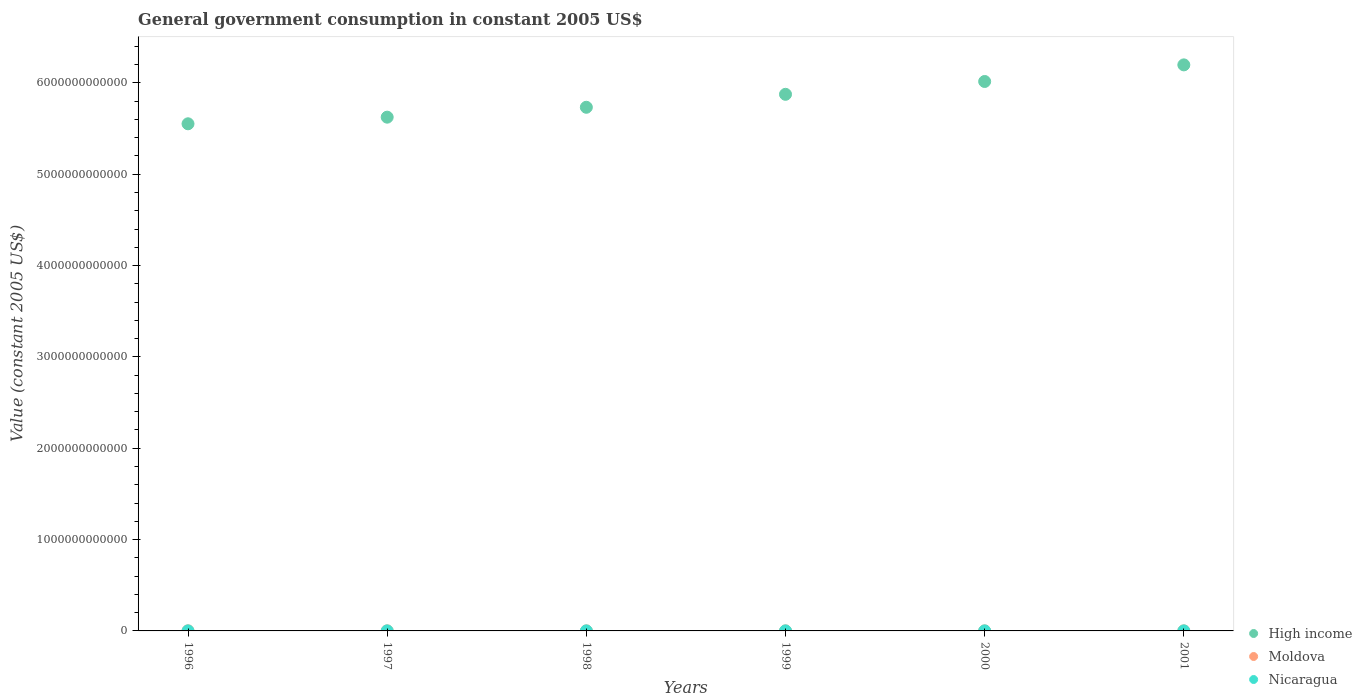How many different coloured dotlines are there?
Keep it short and to the point. 3. What is the government conusmption in Nicaragua in 1999?
Your answer should be very brief. 5.27e+08. Across all years, what is the maximum government conusmption in High income?
Your answer should be compact. 6.20e+12. Across all years, what is the minimum government conusmption in Moldova?
Keep it short and to the point. 2.83e+08. In which year was the government conusmption in Moldova minimum?
Make the answer very short. 1999. What is the total government conusmption in Moldova in the graph?
Ensure brevity in your answer.  2.62e+09. What is the difference between the government conusmption in Moldova in 1997 and that in 2000?
Offer a terse response. 2.41e+08. What is the difference between the government conusmption in Moldova in 1997 and the government conusmption in High income in 2001?
Offer a very short reply. -6.20e+12. What is the average government conusmption in High income per year?
Make the answer very short. 5.83e+12. In the year 1999, what is the difference between the government conusmption in Nicaragua and government conusmption in High income?
Provide a short and direct response. -5.87e+12. What is the ratio of the government conusmption in High income in 1997 to that in 1998?
Offer a terse response. 0.98. What is the difference between the highest and the second highest government conusmption in Moldova?
Offer a terse response. 2.06e+08. What is the difference between the highest and the lowest government conusmption in Nicaragua?
Make the answer very short. 8.57e+07. In how many years, is the government conusmption in Moldova greater than the average government conusmption in Moldova taken over all years?
Make the answer very short. 2. Is the sum of the government conusmption in High income in 1997 and 2000 greater than the maximum government conusmption in Nicaragua across all years?
Keep it short and to the point. Yes. Is it the case that in every year, the sum of the government conusmption in High income and government conusmption in Nicaragua  is greater than the government conusmption in Moldova?
Offer a very short reply. Yes. Does the government conusmption in Nicaragua monotonically increase over the years?
Your response must be concise. No. Is the government conusmption in Moldova strictly greater than the government conusmption in High income over the years?
Your answer should be compact. No. Is the government conusmption in Nicaragua strictly less than the government conusmption in High income over the years?
Offer a terse response. Yes. How many years are there in the graph?
Offer a terse response. 6. What is the difference between two consecutive major ticks on the Y-axis?
Keep it short and to the point. 1.00e+12. Are the values on the major ticks of Y-axis written in scientific E-notation?
Your answer should be very brief. No. How many legend labels are there?
Give a very brief answer. 3. How are the legend labels stacked?
Provide a succinct answer. Vertical. What is the title of the graph?
Give a very brief answer. General government consumption in constant 2005 US$. Does "Kyrgyz Republic" appear as one of the legend labels in the graph?
Provide a succinct answer. No. What is the label or title of the Y-axis?
Offer a very short reply. Value (constant 2005 US$). What is the Value (constant 2005 US$) of High income in 1996?
Offer a terse response. 5.55e+12. What is the Value (constant 2005 US$) in Moldova in 1996?
Offer a very short reply. 7.36e+08. What is the Value (constant 2005 US$) of Nicaragua in 1996?
Make the answer very short. 4.87e+08. What is the Value (constant 2005 US$) of High income in 1997?
Your answer should be compact. 5.63e+12. What is the Value (constant 2005 US$) of Moldova in 1997?
Provide a short and direct response. 5.30e+08. What is the Value (constant 2005 US$) in Nicaragua in 1997?
Keep it short and to the point. 4.67e+08. What is the Value (constant 2005 US$) in High income in 1998?
Your response must be concise. 5.73e+12. What is the Value (constant 2005 US$) in Moldova in 1998?
Keep it short and to the point. 3.69e+08. What is the Value (constant 2005 US$) of Nicaragua in 1998?
Your answer should be compact. 4.87e+08. What is the Value (constant 2005 US$) of High income in 1999?
Provide a short and direct response. 5.88e+12. What is the Value (constant 2005 US$) of Moldova in 1999?
Make the answer very short. 2.83e+08. What is the Value (constant 2005 US$) in Nicaragua in 1999?
Provide a succinct answer. 5.27e+08. What is the Value (constant 2005 US$) in High income in 2000?
Offer a very short reply. 6.02e+12. What is the Value (constant 2005 US$) in Moldova in 2000?
Keep it short and to the point. 2.89e+08. What is the Value (constant 2005 US$) of Nicaragua in 2000?
Keep it short and to the point. 5.53e+08. What is the Value (constant 2005 US$) of High income in 2001?
Offer a terse response. 6.20e+12. What is the Value (constant 2005 US$) of Moldova in 2001?
Offer a terse response. 4.10e+08. What is the Value (constant 2005 US$) in Nicaragua in 2001?
Offer a terse response. 5.37e+08. Across all years, what is the maximum Value (constant 2005 US$) in High income?
Offer a very short reply. 6.20e+12. Across all years, what is the maximum Value (constant 2005 US$) in Moldova?
Offer a very short reply. 7.36e+08. Across all years, what is the maximum Value (constant 2005 US$) of Nicaragua?
Offer a terse response. 5.53e+08. Across all years, what is the minimum Value (constant 2005 US$) of High income?
Your answer should be compact. 5.55e+12. Across all years, what is the minimum Value (constant 2005 US$) of Moldova?
Provide a short and direct response. 2.83e+08. Across all years, what is the minimum Value (constant 2005 US$) in Nicaragua?
Keep it short and to the point. 4.67e+08. What is the total Value (constant 2005 US$) of High income in the graph?
Offer a very short reply. 3.50e+13. What is the total Value (constant 2005 US$) of Moldova in the graph?
Offer a terse response. 2.62e+09. What is the total Value (constant 2005 US$) in Nicaragua in the graph?
Keep it short and to the point. 3.06e+09. What is the difference between the Value (constant 2005 US$) of High income in 1996 and that in 1997?
Provide a short and direct response. -7.26e+1. What is the difference between the Value (constant 2005 US$) in Moldova in 1996 and that in 1997?
Your response must be concise. 2.06e+08. What is the difference between the Value (constant 2005 US$) in Nicaragua in 1996 and that in 1997?
Your response must be concise. 2.01e+07. What is the difference between the Value (constant 2005 US$) in High income in 1996 and that in 1998?
Offer a terse response. -1.81e+11. What is the difference between the Value (constant 2005 US$) of Moldova in 1996 and that in 1998?
Make the answer very short. 3.68e+08. What is the difference between the Value (constant 2005 US$) in Nicaragua in 1996 and that in 1998?
Ensure brevity in your answer.  -2.91e+05. What is the difference between the Value (constant 2005 US$) in High income in 1996 and that in 1999?
Make the answer very short. -3.23e+11. What is the difference between the Value (constant 2005 US$) of Moldova in 1996 and that in 1999?
Provide a short and direct response. 4.53e+08. What is the difference between the Value (constant 2005 US$) in Nicaragua in 1996 and that in 1999?
Your response must be concise. -4.02e+07. What is the difference between the Value (constant 2005 US$) of High income in 1996 and that in 2000?
Offer a terse response. -4.63e+11. What is the difference between the Value (constant 2005 US$) of Moldova in 1996 and that in 2000?
Your answer should be compact. 4.47e+08. What is the difference between the Value (constant 2005 US$) of Nicaragua in 1996 and that in 2000?
Keep it short and to the point. -6.56e+07. What is the difference between the Value (constant 2005 US$) of High income in 1996 and that in 2001?
Provide a short and direct response. -6.45e+11. What is the difference between the Value (constant 2005 US$) in Moldova in 1996 and that in 2001?
Your answer should be compact. 3.26e+08. What is the difference between the Value (constant 2005 US$) in Nicaragua in 1996 and that in 2001?
Provide a short and direct response. -4.96e+07. What is the difference between the Value (constant 2005 US$) in High income in 1997 and that in 1998?
Ensure brevity in your answer.  -1.08e+11. What is the difference between the Value (constant 2005 US$) of Moldova in 1997 and that in 1998?
Provide a short and direct response. 1.61e+08. What is the difference between the Value (constant 2005 US$) of Nicaragua in 1997 and that in 1998?
Offer a terse response. -2.04e+07. What is the difference between the Value (constant 2005 US$) in High income in 1997 and that in 1999?
Keep it short and to the point. -2.50e+11. What is the difference between the Value (constant 2005 US$) in Moldova in 1997 and that in 1999?
Make the answer very short. 2.47e+08. What is the difference between the Value (constant 2005 US$) of Nicaragua in 1997 and that in 1999?
Offer a terse response. -6.04e+07. What is the difference between the Value (constant 2005 US$) in High income in 1997 and that in 2000?
Keep it short and to the point. -3.91e+11. What is the difference between the Value (constant 2005 US$) of Moldova in 1997 and that in 2000?
Offer a terse response. 2.41e+08. What is the difference between the Value (constant 2005 US$) of Nicaragua in 1997 and that in 2000?
Ensure brevity in your answer.  -8.57e+07. What is the difference between the Value (constant 2005 US$) in High income in 1997 and that in 2001?
Offer a terse response. -5.73e+11. What is the difference between the Value (constant 2005 US$) of Moldova in 1997 and that in 2001?
Give a very brief answer. 1.20e+08. What is the difference between the Value (constant 2005 US$) of Nicaragua in 1997 and that in 2001?
Offer a terse response. -6.97e+07. What is the difference between the Value (constant 2005 US$) in High income in 1998 and that in 1999?
Provide a short and direct response. -1.42e+11. What is the difference between the Value (constant 2005 US$) in Moldova in 1998 and that in 1999?
Give a very brief answer. 8.54e+07. What is the difference between the Value (constant 2005 US$) of Nicaragua in 1998 and that in 1999?
Keep it short and to the point. -3.99e+07. What is the difference between the Value (constant 2005 US$) in High income in 1998 and that in 2000?
Your answer should be very brief. -2.82e+11. What is the difference between the Value (constant 2005 US$) of Moldova in 1998 and that in 2000?
Provide a succinct answer. 7.98e+07. What is the difference between the Value (constant 2005 US$) of Nicaragua in 1998 and that in 2000?
Give a very brief answer. -6.53e+07. What is the difference between the Value (constant 2005 US$) of High income in 1998 and that in 2001?
Ensure brevity in your answer.  -4.64e+11. What is the difference between the Value (constant 2005 US$) in Moldova in 1998 and that in 2001?
Offer a very short reply. -4.18e+07. What is the difference between the Value (constant 2005 US$) of Nicaragua in 1998 and that in 2001?
Make the answer very short. -4.93e+07. What is the difference between the Value (constant 2005 US$) in High income in 1999 and that in 2000?
Your answer should be compact. -1.40e+11. What is the difference between the Value (constant 2005 US$) of Moldova in 1999 and that in 2000?
Offer a very short reply. -5.61e+06. What is the difference between the Value (constant 2005 US$) of Nicaragua in 1999 and that in 2000?
Your answer should be very brief. -2.54e+07. What is the difference between the Value (constant 2005 US$) in High income in 1999 and that in 2001?
Provide a succinct answer. -3.22e+11. What is the difference between the Value (constant 2005 US$) in Moldova in 1999 and that in 2001?
Provide a short and direct response. -1.27e+08. What is the difference between the Value (constant 2005 US$) in Nicaragua in 1999 and that in 2001?
Give a very brief answer. -9.35e+06. What is the difference between the Value (constant 2005 US$) of High income in 2000 and that in 2001?
Keep it short and to the point. -1.82e+11. What is the difference between the Value (constant 2005 US$) of Moldova in 2000 and that in 2001?
Offer a very short reply. -1.22e+08. What is the difference between the Value (constant 2005 US$) of Nicaragua in 2000 and that in 2001?
Ensure brevity in your answer.  1.60e+07. What is the difference between the Value (constant 2005 US$) of High income in 1996 and the Value (constant 2005 US$) of Moldova in 1997?
Give a very brief answer. 5.55e+12. What is the difference between the Value (constant 2005 US$) in High income in 1996 and the Value (constant 2005 US$) in Nicaragua in 1997?
Offer a very short reply. 5.55e+12. What is the difference between the Value (constant 2005 US$) in Moldova in 1996 and the Value (constant 2005 US$) in Nicaragua in 1997?
Offer a very short reply. 2.69e+08. What is the difference between the Value (constant 2005 US$) in High income in 1996 and the Value (constant 2005 US$) in Moldova in 1998?
Offer a terse response. 5.55e+12. What is the difference between the Value (constant 2005 US$) in High income in 1996 and the Value (constant 2005 US$) in Nicaragua in 1998?
Make the answer very short. 5.55e+12. What is the difference between the Value (constant 2005 US$) in Moldova in 1996 and the Value (constant 2005 US$) in Nicaragua in 1998?
Provide a short and direct response. 2.49e+08. What is the difference between the Value (constant 2005 US$) in High income in 1996 and the Value (constant 2005 US$) in Moldova in 1999?
Your answer should be compact. 5.55e+12. What is the difference between the Value (constant 2005 US$) of High income in 1996 and the Value (constant 2005 US$) of Nicaragua in 1999?
Provide a succinct answer. 5.55e+12. What is the difference between the Value (constant 2005 US$) of Moldova in 1996 and the Value (constant 2005 US$) of Nicaragua in 1999?
Offer a terse response. 2.09e+08. What is the difference between the Value (constant 2005 US$) in High income in 1996 and the Value (constant 2005 US$) in Moldova in 2000?
Your answer should be very brief. 5.55e+12. What is the difference between the Value (constant 2005 US$) of High income in 1996 and the Value (constant 2005 US$) of Nicaragua in 2000?
Provide a succinct answer. 5.55e+12. What is the difference between the Value (constant 2005 US$) in Moldova in 1996 and the Value (constant 2005 US$) in Nicaragua in 2000?
Provide a short and direct response. 1.84e+08. What is the difference between the Value (constant 2005 US$) of High income in 1996 and the Value (constant 2005 US$) of Moldova in 2001?
Keep it short and to the point. 5.55e+12. What is the difference between the Value (constant 2005 US$) in High income in 1996 and the Value (constant 2005 US$) in Nicaragua in 2001?
Give a very brief answer. 5.55e+12. What is the difference between the Value (constant 2005 US$) of Moldova in 1996 and the Value (constant 2005 US$) of Nicaragua in 2001?
Offer a very short reply. 2.00e+08. What is the difference between the Value (constant 2005 US$) in High income in 1997 and the Value (constant 2005 US$) in Moldova in 1998?
Make the answer very short. 5.62e+12. What is the difference between the Value (constant 2005 US$) of High income in 1997 and the Value (constant 2005 US$) of Nicaragua in 1998?
Your answer should be compact. 5.62e+12. What is the difference between the Value (constant 2005 US$) of Moldova in 1997 and the Value (constant 2005 US$) of Nicaragua in 1998?
Your answer should be very brief. 4.28e+07. What is the difference between the Value (constant 2005 US$) in High income in 1997 and the Value (constant 2005 US$) in Moldova in 1999?
Provide a succinct answer. 5.62e+12. What is the difference between the Value (constant 2005 US$) of High income in 1997 and the Value (constant 2005 US$) of Nicaragua in 1999?
Your answer should be very brief. 5.62e+12. What is the difference between the Value (constant 2005 US$) of Moldova in 1997 and the Value (constant 2005 US$) of Nicaragua in 1999?
Your answer should be compact. 2.86e+06. What is the difference between the Value (constant 2005 US$) in High income in 1997 and the Value (constant 2005 US$) in Moldova in 2000?
Provide a succinct answer. 5.62e+12. What is the difference between the Value (constant 2005 US$) in High income in 1997 and the Value (constant 2005 US$) in Nicaragua in 2000?
Offer a terse response. 5.62e+12. What is the difference between the Value (constant 2005 US$) in Moldova in 1997 and the Value (constant 2005 US$) in Nicaragua in 2000?
Keep it short and to the point. -2.25e+07. What is the difference between the Value (constant 2005 US$) of High income in 1997 and the Value (constant 2005 US$) of Moldova in 2001?
Keep it short and to the point. 5.62e+12. What is the difference between the Value (constant 2005 US$) of High income in 1997 and the Value (constant 2005 US$) of Nicaragua in 2001?
Make the answer very short. 5.62e+12. What is the difference between the Value (constant 2005 US$) of Moldova in 1997 and the Value (constant 2005 US$) of Nicaragua in 2001?
Your answer should be very brief. -6.48e+06. What is the difference between the Value (constant 2005 US$) of High income in 1998 and the Value (constant 2005 US$) of Moldova in 1999?
Provide a short and direct response. 5.73e+12. What is the difference between the Value (constant 2005 US$) in High income in 1998 and the Value (constant 2005 US$) in Nicaragua in 1999?
Keep it short and to the point. 5.73e+12. What is the difference between the Value (constant 2005 US$) in Moldova in 1998 and the Value (constant 2005 US$) in Nicaragua in 1999?
Your answer should be compact. -1.59e+08. What is the difference between the Value (constant 2005 US$) in High income in 1998 and the Value (constant 2005 US$) in Moldova in 2000?
Offer a terse response. 5.73e+12. What is the difference between the Value (constant 2005 US$) of High income in 1998 and the Value (constant 2005 US$) of Nicaragua in 2000?
Your answer should be very brief. 5.73e+12. What is the difference between the Value (constant 2005 US$) of Moldova in 1998 and the Value (constant 2005 US$) of Nicaragua in 2000?
Provide a short and direct response. -1.84e+08. What is the difference between the Value (constant 2005 US$) in High income in 1998 and the Value (constant 2005 US$) in Moldova in 2001?
Offer a terse response. 5.73e+12. What is the difference between the Value (constant 2005 US$) in High income in 1998 and the Value (constant 2005 US$) in Nicaragua in 2001?
Make the answer very short. 5.73e+12. What is the difference between the Value (constant 2005 US$) in Moldova in 1998 and the Value (constant 2005 US$) in Nicaragua in 2001?
Give a very brief answer. -1.68e+08. What is the difference between the Value (constant 2005 US$) of High income in 1999 and the Value (constant 2005 US$) of Moldova in 2000?
Offer a very short reply. 5.87e+12. What is the difference between the Value (constant 2005 US$) in High income in 1999 and the Value (constant 2005 US$) in Nicaragua in 2000?
Offer a terse response. 5.87e+12. What is the difference between the Value (constant 2005 US$) in Moldova in 1999 and the Value (constant 2005 US$) in Nicaragua in 2000?
Offer a terse response. -2.69e+08. What is the difference between the Value (constant 2005 US$) in High income in 1999 and the Value (constant 2005 US$) in Moldova in 2001?
Offer a very short reply. 5.87e+12. What is the difference between the Value (constant 2005 US$) in High income in 1999 and the Value (constant 2005 US$) in Nicaragua in 2001?
Keep it short and to the point. 5.87e+12. What is the difference between the Value (constant 2005 US$) of Moldova in 1999 and the Value (constant 2005 US$) of Nicaragua in 2001?
Offer a very short reply. -2.53e+08. What is the difference between the Value (constant 2005 US$) in High income in 2000 and the Value (constant 2005 US$) in Moldova in 2001?
Your answer should be compact. 6.02e+12. What is the difference between the Value (constant 2005 US$) of High income in 2000 and the Value (constant 2005 US$) of Nicaragua in 2001?
Your answer should be very brief. 6.02e+12. What is the difference between the Value (constant 2005 US$) of Moldova in 2000 and the Value (constant 2005 US$) of Nicaragua in 2001?
Offer a terse response. -2.48e+08. What is the average Value (constant 2005 US$) of High income per year?
Offer a very short reply. 5.83e+12. What is the average Value (constant 2005 US$) in Moldova per year?
Your response must be concise. 4.36e+08. What is the average Value (constant 2005 US$) in Nicaragua per year?
Your response must be concise. 5.10e+08. In the year 1996, what is the difference between the Value (constant 2005 US$) of High income and Value (constant 2005 US$) of Moldova?
Provide a short and direct response. 5.55e+12. In the year 1996, what is the difference between the Value (constant 2005 US$) in High income and Value (constant 2005 US$) in Nicaragua?
Ensure brevity in your answer.  5.55e+12. In the year 1996, what is the difference between the Value (constant 2005 US$) in Moldova and Value (constant 2005 US$) in Nicaragua?
Ensure brevity in your answer.  2.49e+08. In the year 1997, what is the difference between the Value (constant 2005 US$) of High income and Value (constant 2005 US$) of Moldova?
Offer a very short reply. 5.62e+12. In the year 1997, what is the difference between the Value (constant 2005 US$) of High income and Value (constant 2005 US$) of Nicaragua?
Provide a short and direct response. 5.62e+12. In the year 1997, what is the difference between the Value (constant 2005 US$) of Moldova and Value (constant 2005 US$) of Nicaragua?
Your response must be concise. 6.32e+07. In the year 1998, what is the difference between the Value (constant 2005 US$) in High income and Value (constant 2005 US$) in Moldova?
Your answer should be very brief. 5.73e+12. In the year 1998, what is the difference between the Value (constant 2005 US$) in High income and Value (constant 2005 US$) in Nicaragua?
Give a very brief answer. 5.73e+12. In the year 1998, what is the difference between the Value (constant 2005 US$) of Moldova and Value (constant 2005 US$) of Nicaragua?
Keep it short and to the point. -1.19e+08. In the year 1999, what is the difference between the Value (constant 2005 US$) in High income and Value (constant 2005 US$) in Moldova?
Provide a succinct answer. 5.87e+12. In the year 1999, what is the difference between the Value (constant 2005 US$) of High income and Value (constant 2005 US$) of Nicaragua?
Your response must be concise. 5.87e+12. In the year 1999, what is the difference between the Value (constant 2005 US$) in Moldova and Value (constant 2005 US$) in Nicaragua?
Provide a succinct answer. -2.44e+08. In the year 2000, what is the difference between the Value (constant 2005 US$) of High income and Value (constant 2005 US$) of Moldova?
Provide a short and direct response. 6.02e+12. In the year 2000, what is the difference between the Value (constant 2005 US$) of High income and Value (constant 2005 US$) of Nicaragua?
Your answer should be compact. 6.02e+12. In the year 2000, what is the difference between the Value (constant 2005 US$) of Moldova and Value (constant 2005 US$) of Nicaragua?
Your answer should be very brief. -2.64e+08. In the year 2001, what is the difference between the Value (constant 2005 US$) in High income and Value (constant 2005 US$) in Moldova?
Offer a very short reply. 6.20e+12. In the year 2001, what is the difference between the Value (constant 2005 US$) in High income and Value (constant 2005 US$) in Nicaragua?
Keep it short and to the point. 6.20e+12. In the year 2001, what is the difference between the Value (constant 2005 US$) in Moldova and Value (constant 2005 US$) in Nicaragua?
Keep it short and to the point. -1.26e+08. What is the ratio of the Value (constant 2005 US$) of High income in 1996 to that in 1997?
Ensure brevity in your answer.  0.99. What is the ratio of the Value (constant 2005 US$) of Moldova in 1996 to that in 1997?
Offer a very short reply. 1.39. What is the ratio of the Value (constant 2005 US$) in Nicaragua in 1996 to that in 1997?
Your answer should be very brief. 1.04. What is the ratio of the Value (constant 2005 US$) of High income in 1996 to that in 1998?
Keep it short and to the point. 0.97. What is the ratio of the Value (constant 2005 US$) in Moldova in 1996 to that in 1998?
Your response must be concise. 2. What is the ratio of the Value (constant 2005 US$) in Nicaragua in 1996 to that in 1998?
Give a very brief answer. 1. What is the ratio of the Value (constant 2005 US$) of High income in 1996 to that in 1999?
Keep it short and to the point. 0.95. What is the ratio of the Value (constant 2005 US$) in Moldova in 1996 to that in 1999?
Provide a short and direct response. 2.6. What is the ratio of the Value (constant 2005 US$) of Nicaragua in 1996 to that in 1999?
Make the answer very short. 0.92. What is the ratio of the Value (constant 2005 US$) of High income in 1996 to that in 2000?
Your answer should be compact. 0.92. What is the ratio of the Value (constant 2005 US$) in Moldova in 1996 to that in 2000?
Provide a short and direct response. 2.55. What is the ratio of the Value (constant 2005 US$) in Nicaragua in 1996 to that in 2000?
Give a very brief answer. 0.88. What is the ratio of the Value (constant 2005 US$) in High income in 1996 to that in 2001?
Ensure brevity in your answer.  0.9. What is the ratio of the Value (constant 2005 US$) of Moldova in 1996 to that in 2001?
Your answer should be compact. 1.79. What is the ratio of the Value (constant 2005 US$) of Nicaragua in 1996 to that in 2001?
Keep it short and to the point. 0.91. What is the ratio of the Value (constant 2005 US$) in High income in 1997 to that in 1998?
Your answer should be compact. 0.98. What is the ratio of the Value (constant 2005 US$) of Moldova in 1997 to that in 1998?
Make the answer very short. 1.44. What is the ratio of the Value (constant 2005 US$) of Nicaragua in 1997 to that in 1998?
Give a very brief answer. 0.96. What is the ratio of the Value (constant 2005 US$) in High income in 1997 to that in 1999?
Provide a short and direct response. 0.96. What is the ratio of the Value (constant 2005 US$) of Moldova in 1997 to that in 1999?
Your answer should be compact. 1.87. What is the ratio of the Value (constant 2005 US$) of Nicaragua in 1997 to that in 1999?
Offer a very short reply. 0.89. What is the ratio of the Value (constant 2005 US$) of High income in 1997 to that in 2000?
Give a very brief answer. 0.94. What is the ratio of the Value (constant 2005 US$) in Moldova in 1997 to that in 2000?
Your response must be concise. 1.83. What is the ratio of the Value (constant 2005 US$) of Nicaragua in 1997 to that in 2000?
Ensure brevity in your answer.  0.84. What is the ratio of the Value (constant 2005 US$) of High income in 1997 to that in 2001?
Provide a succinct answer. 0.91. What is the ratio of the Value (constant 2005 US$) of Moldova in 1997 to that in 2001?
Keep it short and to the point. 1.29. What is the ratio of the Value (constant 2005 US$) in Nicaragua in 1997 to that in 2001?
Your answer should be compact. 0.87. What is the ratio of the Value (constant 2005 US$) of High income in 1998 to that in 1999?
Your response must be concise. 0.98. What is the ratio of the Value (constant 2005 US$) in Moldova in 1998 to that in 1999?
Ensure brevity in your answer.  1.3. What is the ratio of the Value (constant 2005 US$) of Nicaragua in 1998 to that in 1999?
Make the answer very short. 0.92. What is the ratio of the Value (constant 2005 US$) in High income in 1998 to that in 2000?
Make the answer very short. 0.95. What is the ratio of the Value (constant 2005 US$) of Moldova in 1998 to that in 2000?
Provide a short and direct response. 1.28. What is the ratio of the Value (constant 2005 US$) of Nicaragua in 1998 to that in 2000?
Offer a very short reply. 0.88. What is the ratio of the Value (constant 2005 US$) in High income in 1998 to that in 2001?
Ensure brevity in your answer.  0.93. What is the ratio of the Value (constant 2005 US$) of Moldova in 1998 to that in 2001?
Your answer should be compact. 0.9. What is the ratio of the Value (constant 2005 US$) in Nicaragua in 1998 to that in 2001?
Your answer should be very brief. 0.91. What is the ratio of the Value (constant 2005 US$) in High income in 1999 to that in 2000?
Offer a very short reply. 0.98. What is the ratio of the Value (constant 2005 US$) in Moldova in 1999 to that in 2000?
Provide a succinct answer. 0.98. What is the ratio of the Value (constant 2005 US$) of Nicaragua in 1999 to that in 2000?
Your response must be concise. 0.95. What is the ratio of the Value (constant 2005 US$) of High income in 1999 to that in 2001?
Your answer should be very brief. 0.95. What is the ratio of the Value (constant 2005 US$) in Moldova in 1999 to that in 2001?
Provide a short and direct response. 0.69. What is the ratio of the Value (constant 2005 US$) of Nicaragua in 1999 to that in 2001?
Your answer should be very brief. 0.98. What is the ratio of the Value (constant 2005 US$) of High income in 2000 to that in 2001?
Provide a succinct answer. 0.97. What is the ratio of the Value (constant 2005 US$) of Moldova in 2000 to that in 2001?
Make the answer very short. 0.7. What is the ratio of the Value (constant 2005 US$) of Nicaragua in 2000 to that in 2001?
Offer a terse response. 1.03. What is the difference between the highest and the second highest Value (constant 2005 US$) in High income?
Keep it short and to the point. 1.82e+11. What is the difference between the highest and the second highest Value (constant 2005 US$) of Moldova?
Provide a succinct answer. 2.06e+08. What is the difference between the highest and the second highest Value (constant 2005 US$) of Nicaragua?
Offer a very short reply. 1.60e+07. What is the difference between the highest and the lowest Value (constant 2005 US$) in High income?
Offer a very short reply. 6.45e+11. What is the difference between the highest and the lowest Value (constant 2005 US$) in Moldova?
Offer a very short reply. 4.53e+08. What is the difference between the highest and the lowest Value (constant 2005 US$) of Nicaragua?
Keep it short and to the point. 8.57e+07. 